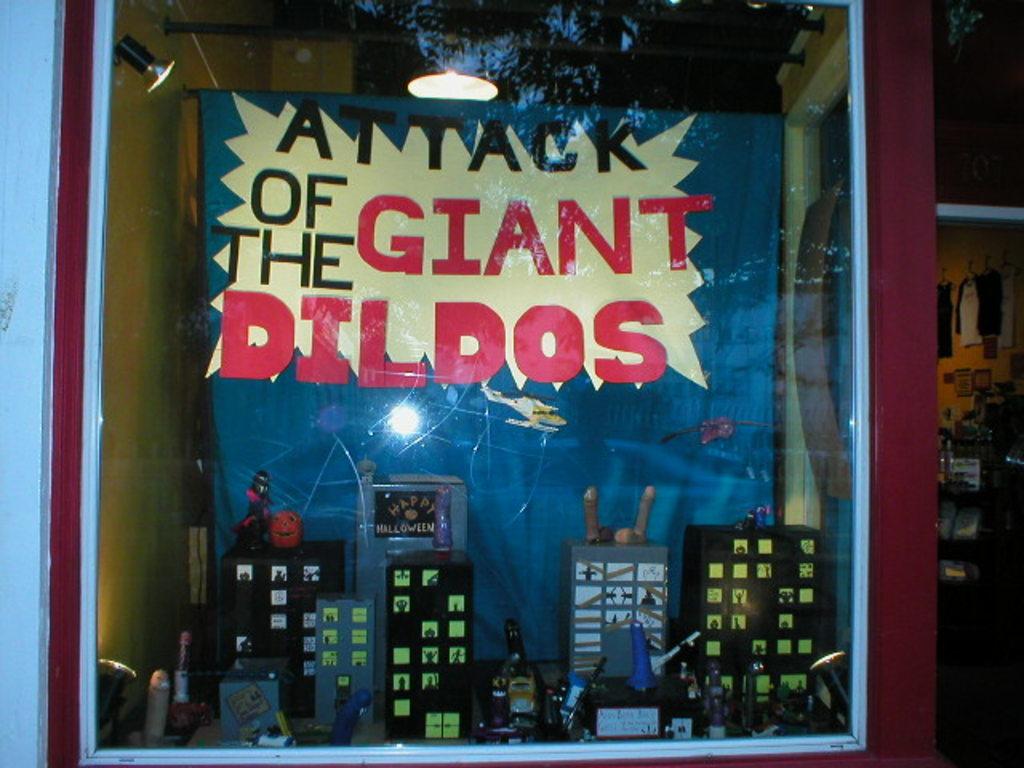How many letter "a"s are there in this display sign?
Ensure brevity in your answer.  3. What is attacking the town?
Provide a succinct answer. Giant dildos. 